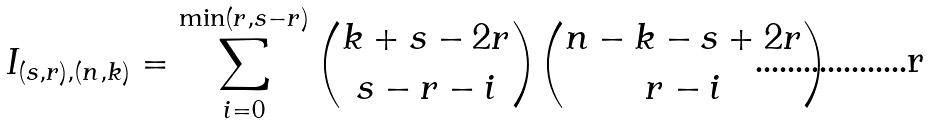<formula> <loc_0><loc_0><loc_500><loc_500>I _ { ( s , r ) , ( n , k ) } = \sum _ { i = 0 } ^ { \min ( r , s - r ) } \binom { k + s - 2 r } { s - r - i } \binom { n - k - s + 2 r } { r - i }</formula> 